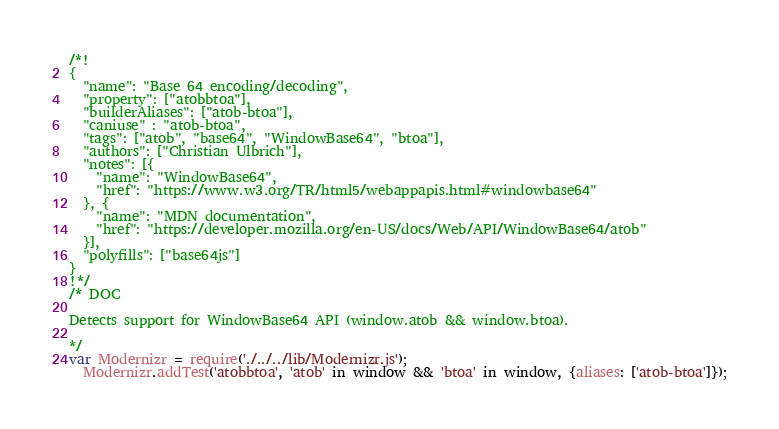Convert code to text. <code><loc_0><loc_0><loc_500><loc_500><_JavaScript_>/*!
{
  "name": "Base 64 encoding/decoding",
  "property": ["atobbtoa"],
  "builderAliases": ["atob-btoa"],
  "caniuse" : "atob-btoa",
  "tags": ["atob", "base64", "WindowBase64", "btoa"],
  "authors": ["Christian Ulbrich"],
  "notes": [{
    "name": "WindowBase64",
    "href": "https://www.w3.org/TR/html5/webappapis.html#windowbase64"
  }, {
    "name": "MDN documentation",
    "href": "https://developer.mozilla.org/en-US/docs/Web/API/WindowBase64/atob"
  }],
  "polyfills": ["base64js"]
}
!*/
/* DOC

Detects support for WindowBase64 API (window.atob && window.btoa).

*/
var Modernizr = require('./../../lib/Modernizr.js');
  Modernizr.addTest('atobbtoa', 'atob' in window && 'btoa' in window, {aliases: ['atob-btoa']});

</code> 